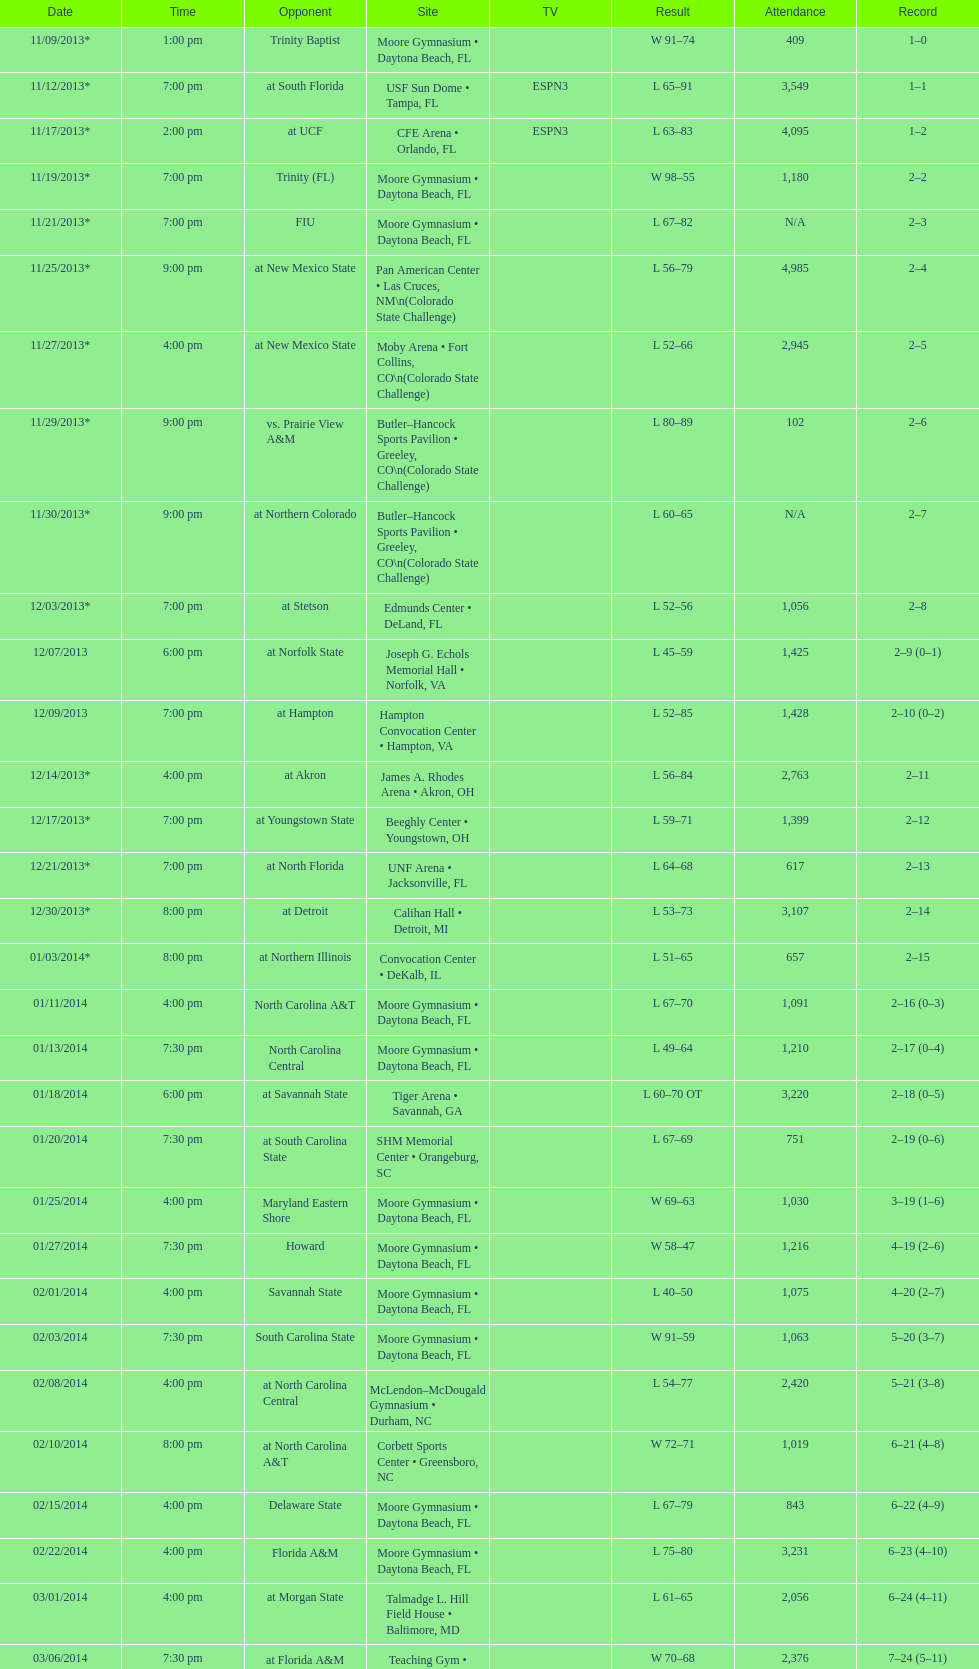How many games witnessed a crowd of more than 1,500 attendees? 12. 